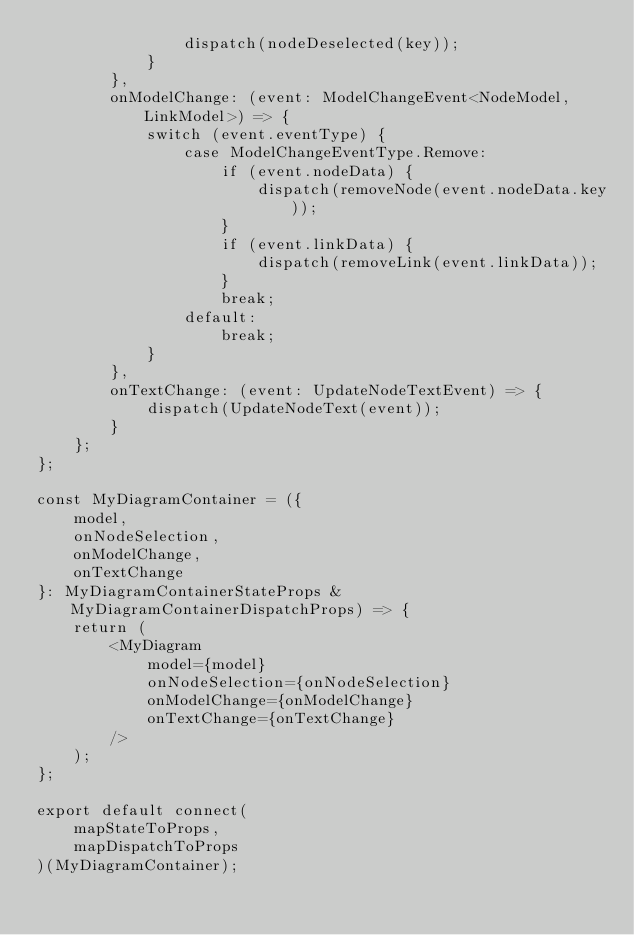<code> <loc_0><loc_0><loc_500><loc_500><_TypeScript_>                dispatch(nodeDeselected(key));
            }
        },
        onModelChange: (event: ModelChangeEvent<NodeModel, LinkModel>) => {
            switch (event.eventType) {
                case ModelChangeEventType.Remove:
                    if (event.nodeData) {
                        dispatch(removeNode(event.nodeData.key));
                    }
                    if (event.linkData) {
                        dispatch(removeLink(event.linkData));
                    }
                    break;
                default:
                    break;
            }
        },
        onTextChange: (event: UpdateNodeTextEvent) => {
            dispatch(UpdateNodeText(event));
        }
    };
};

const MyDiagramContainer = ({
    model,
    onNodeSelection,
    onModelChange,
    onTextChange
}: MyDiagramContainerStateProps & MyDiagramContainerDispatchProps) => {
    return (
        <MyDiagram
            model={model}
            onNodeSelection={onNodeSelection}
            onModelChange={onModelChange}
            onTextChange={onTextChange}
        />
    );
};

export default connect(
    mapStateToProps,
    mapDispatchToProps
)(MyDiagramContainer);
</code> 